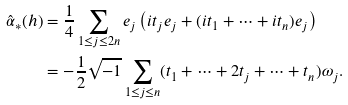Convert formula to latex. <formula><loc_0><loc_0><loc_500><loc_500>\hat { \alpha } _ { * } ( h ) & = \frac { 1 } { 4 } \sum _ { 1 \leq j \leq 2 n } e _ { j } \left ( i t _ { j } e _ { j } + ( i t _ { 1 } + \dots + i t _ { n } ) e _ { j } \right ) \\ & = - \frac { 1 } { 2 } \sqrt { - 1 } \sum _ { 1 \leq j \leq n } ( t _ { 1 } + \dots + 2 t _ { j } + \dots + t _ { n } ) \omega _ { j } .</formula> 